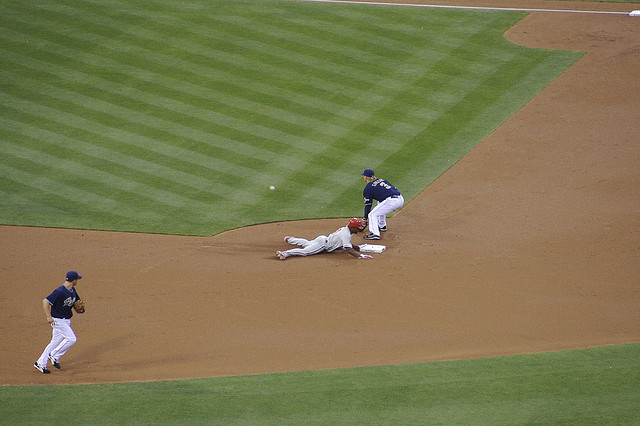<image>What direction was the grass mowed? I am not sure about the direction the grass was mowed. It could be in a checkered or crosshatch pattern, or in an "up and down" manner. What direction was the grass mowed? I am not sure what direction the grass was mowed. It can be seen in a checkered pattern, up and down, or left. 